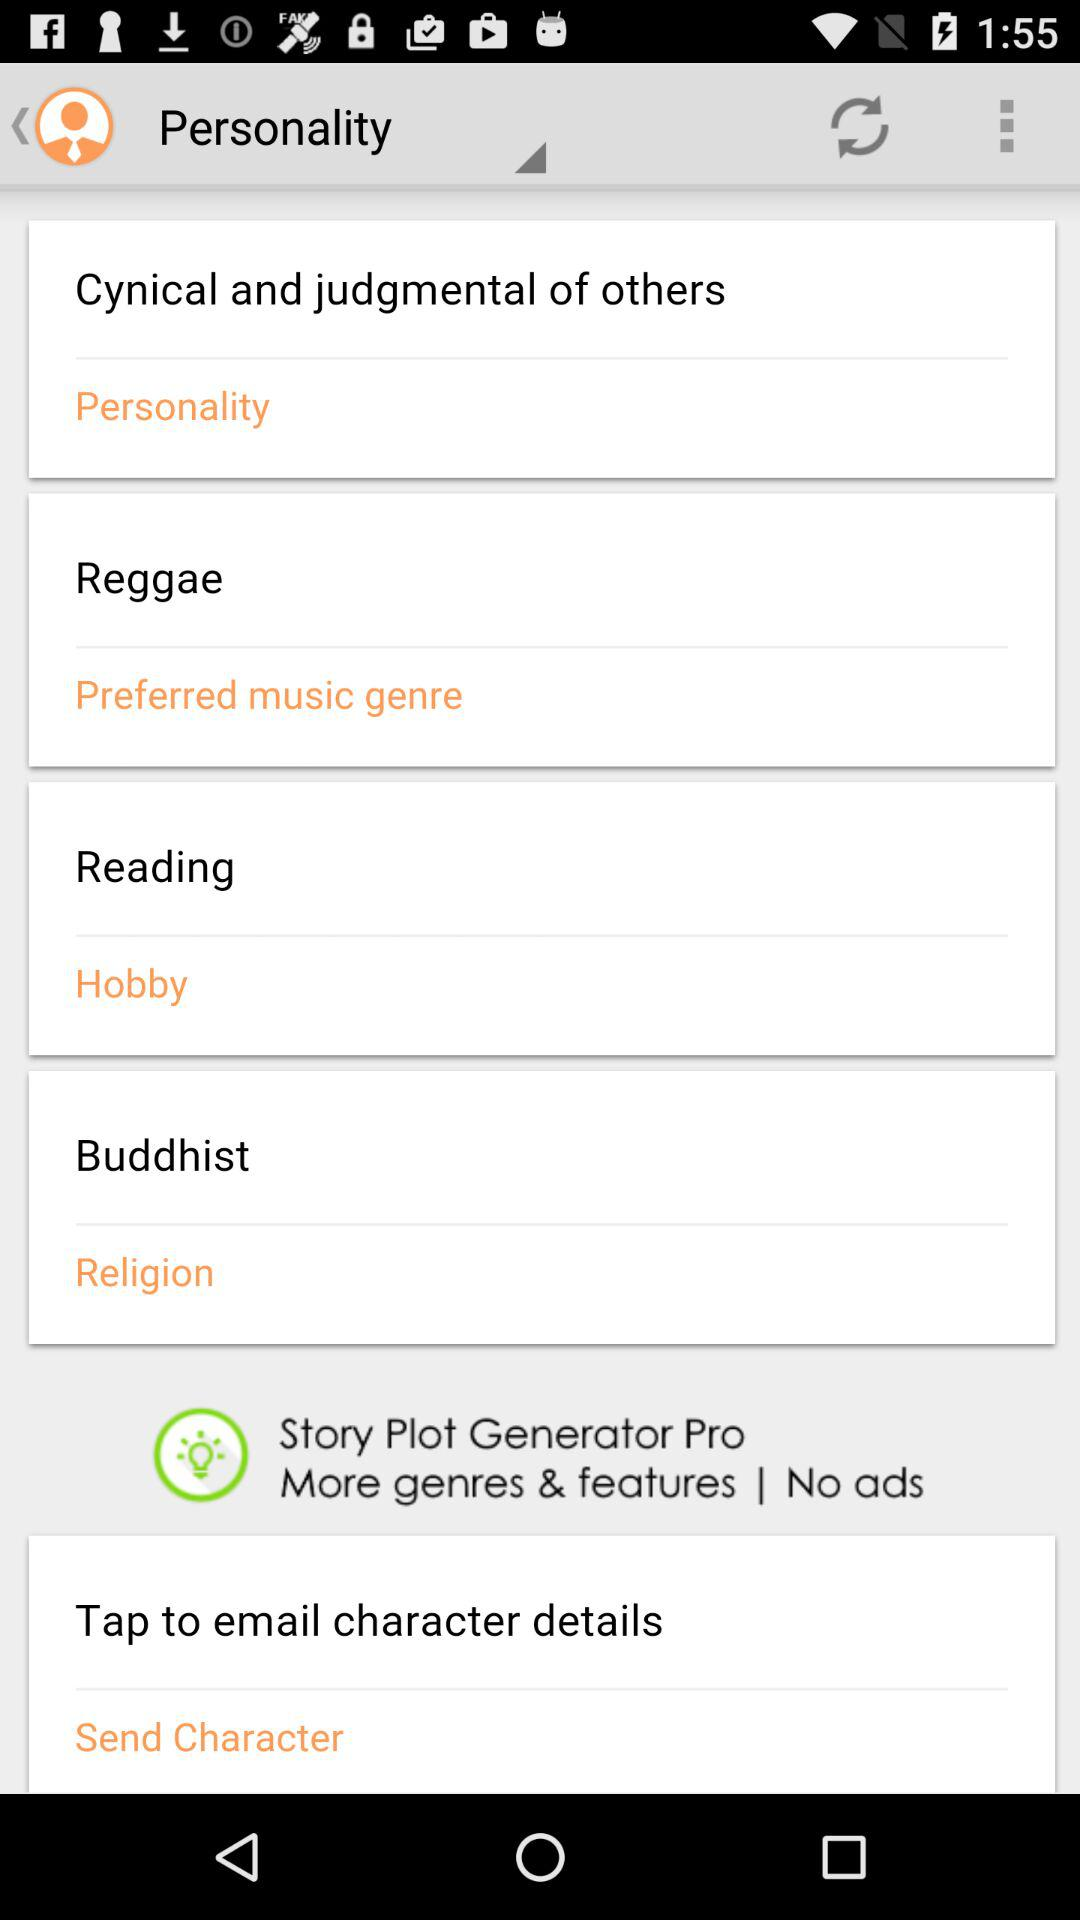What is the character's name?
When the provided information is insufficient, respond with <no answer>. <no answer> 